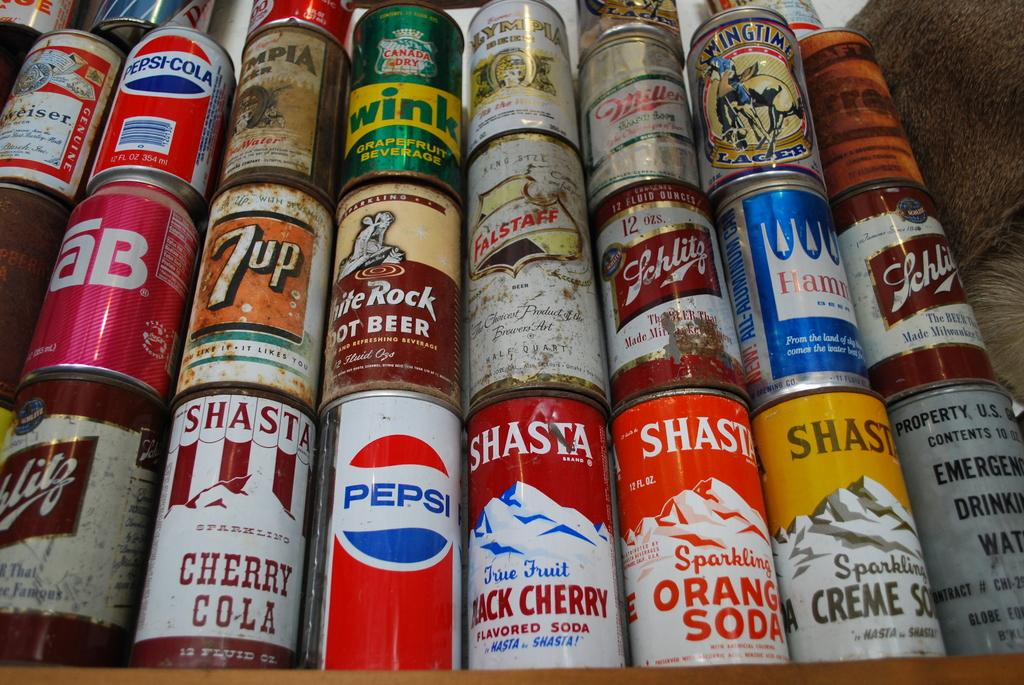<image>
Render a clear and concise summary of the photo. Several different beverage cans such as Tab, Pepsi, and Shasta are stacked on top of each other. 